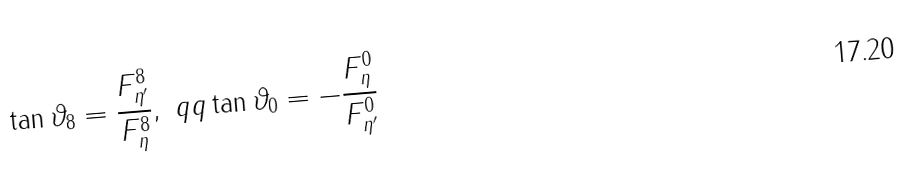Convert formula to latex. <formula><loc_0><loc_0><loc_500><loc_500>\tan \vartheta _ { 8 } = \frac { F _ { \eta ^ { \prime } } ^ { 8 } } { F _ { \eta } ^ { 8 } } , \ q q \tan \vartheta _ { 0 } = - \frac { F _ { \eta } ^ { 0 } } { F _ { \eta ^ { \prime } } ^ { 0 } }</formula> 